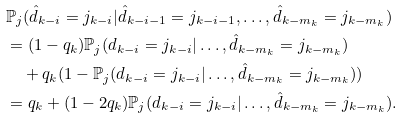Convert formula to latex. <formula><loc_0><loc_0><loc_500><loc_500>& \mathbb { P } _ { j } ( \hat { d } _ { k - i } = j _ { k - i } | \hat { d } _ { k - i - 1 } = j _ { k - i - 1 } , \dots , \hat { d } _ { k - m _ { k } } = j _ { k - m _ { k } } ) \\ & = ( 1 - q _ { k } ) \mathbb { P } _ { j } ( d _ { k - i } = j _ { k - i } | \dots , \hat { d } _ { k - m _ { k } } = j _ { k - m _ { k } } ) \\ & \quad + q _ { k } ( 1 - \mathbb { P } _ { j } ( d _ { k - i } = j _ { k - i } | \dots , \hat { d } _ { k - m _ { k } } = j _ { k - m _ { k } } ) ) \\ & = q _ { k } + ( 1 - 2 q _ { k } ) \mathbb { P } _ { j } ( d _ { k - i } = j _ { k - i } | \dots , \hat { d } _ { k - m _ { k } } = j _ { k - m _ { k } } ) .</formula> 